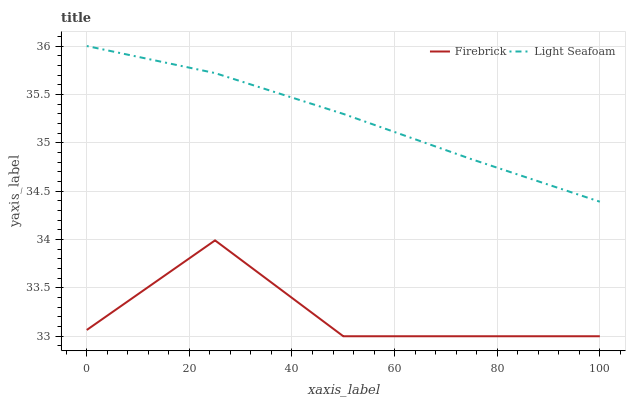Does Firebrick have the minimum area under the curve?
Answer yes or no. Yes. Does Light Seafoam have the maximum area under the curve?
Answer yes or no. Yes. Does Light Seafoam have the minimum area under the curve?
Answer yes or no. No. Is Light Seafoam the smoothest?
Answer yes or no. Yes. Is Firebrick the roughest?
Answer yes or no. Yes. Is Light Seafoam the roughest?
Answer yes or no. No. Does Firebrick have the lowest value?
Answer yes or no. Yes. Does Light Seafoam have the lowest value?
Answer yes or no. No. Does Light Seafoam have the highest value?
Answer yes or no. Yes. Is Firebrick less than Light Seafoam?
Answer yes or no. Yes. Is Light Seafoam greater than Firebrick?
Answer yes or no. Yes. Does Firebrick intersect Light Seafoam?
Answer yes or no. No. 